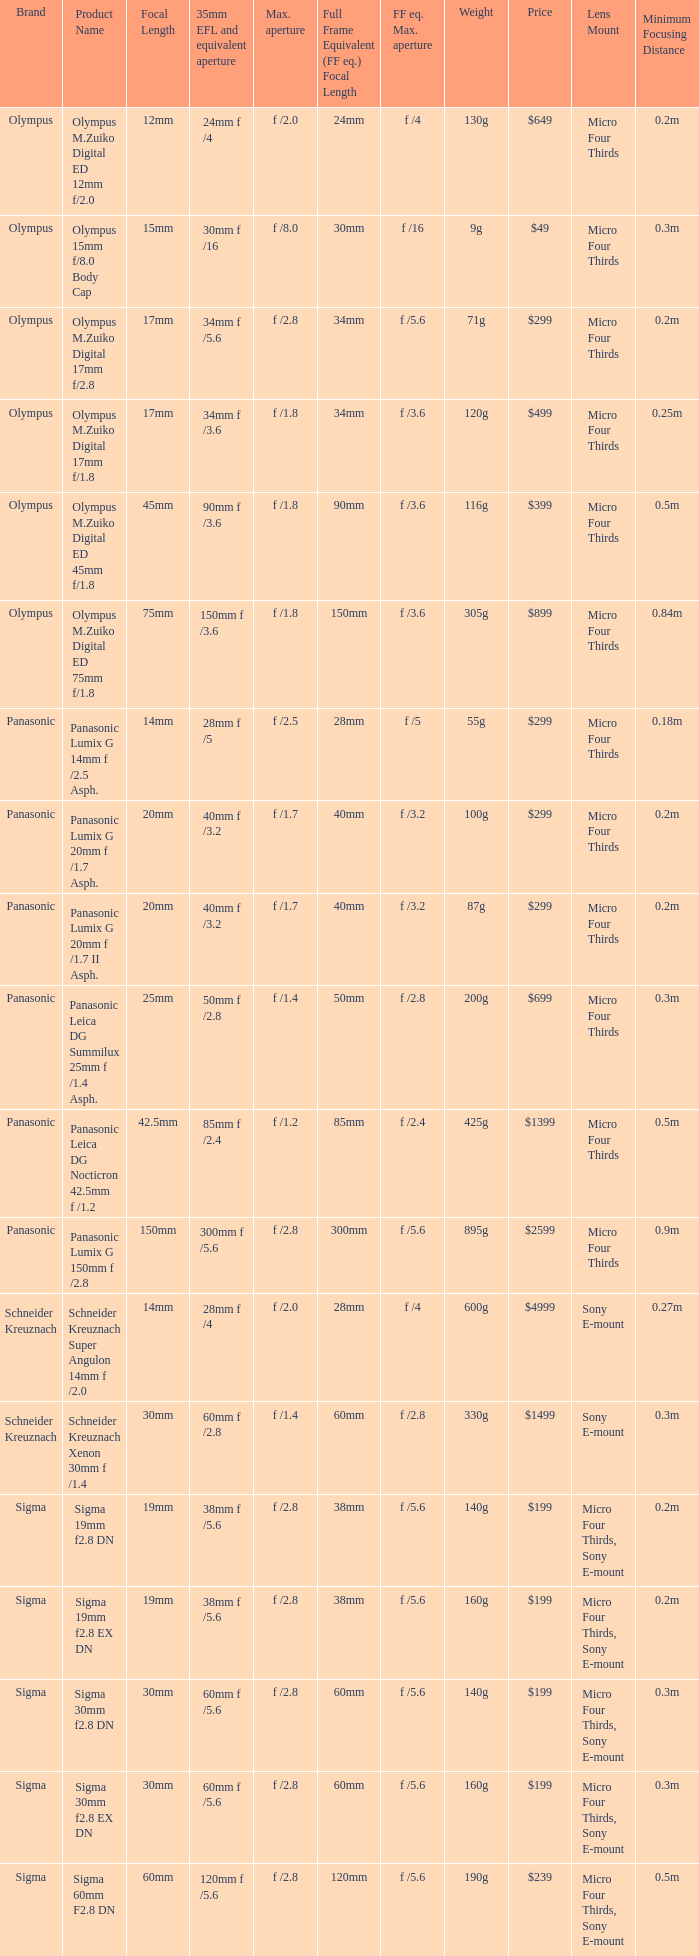Could you parse the entire table as a dict? {'header': ['Brand', 'Product Name', 'Focal Length', '35mm EFL and equivalent aperture', 'Max. aperture', 'Full Frame Equivalent (FF eq.) Focal Length', 'FF eq. Max. aperture', 'Weight', 'Price', 'Lens Mount', 'Minimum Focusing Distance'], 'rows': [['Olympus', 'Olympus M.Zuiko Digital ED 12mm f/2.0', '12mm', '24mm f /4', 'f /2.0', '24mm', 'f /4', '130g', '$649', 'Micro Four Thirds', '0.2m'], ['Olympus', 'Olympus 15mm f/8.0 Body Cap', '15mm', '30mm f /16', 'f /8.0', '30mm', 'f /16', '9g', '$49', 'Micro Four Thirds', '0.3m'], ['Olympus', 'Olympus M.Zuiko Digital 17mm f/2.8', '17mm', '34mm f /5.6', 'f /2.8', '34mm', 'f /5.6', '71g', '$299', 'Micro Four Thirds', '0.2m'], ['Olympus', 'Olympus M.Zuiko Digital 17mm f/1.8', '17mm', '34mm f /3.6', 'f /1.8', '34mm', 'f /3.6', '120g', '$499', 'Micro Four Thirds', '0.25m'], ['Olympus', 'Olympus M.Zuiko Digital ED 45mm f/1.8', '45mm', '90mm f /3.6', 'f /1.8', '90mm', 'f /3.6', '116g', '$399', 'Micro Four Thirds', '0.5m'], ['Olympus', 'Olympus M.Zuiko Digital ED 75mm f/1.8', '75mm', '150mm f /3.6', 'f /1.8', '150mm', 'f /3.6', '305g', '$899', 'Micro Four Thirds', '0.84m'], ['Panasonic', 'Panasonic Lumix G 14mm f /2.5 Asph.', '14mm', '28mm f /5', 'f /2.5', '28mm', 'f /5', '55g', '$299', 'Micro Four Thirds', '0.18m'], ['Panasonic', 'Panasonic Lumix G 20mm f /1.7 Asph.', '20mm', '40mm f /3.2', 'f /1.7', '40mm', 'f /3.2', '100g', '$299', 'Micro Four Thirds', '0.2m'], ['Panasonic', 'Panasonic Lumix G 20mm f /1.7 II Asph.', '20mm', '40mm f /3.2', 'f /1.7', '40mm', 'f /3.2', '87g', '$299', 'Micro Four Thirds', '0.2m'], ['Panasonic', 'Panasonic Leica DG Summilux 25mm f /1.4 Asph.', '25mm', '50mm f /2.8', 'f /1.4', '50mm', 'f /2.8', '200g', '$699', 'Micro Four Thirds', '0.3m'], ['Panasonic', 'Panasonic Leica DG Nocticron 42.5mm f /1.2', '42.5mm', '85mm f /2.4', 'f /1.2', '85mm', 'f /2.4', '425g', '$1399', 'Micro Four Thirds', '0.5m'], ['Panasonic', 'Panasonic Lumix G 150mm f /2.8', '150mm', '300mm f /5.6', 'f /2.8', '300mm', 'f /5.6', '895g', '$2599', 'Micro Four Thirds', '0.9m'], ['Schneider Kreuznach', 'Schneider Kreuznach Super Angulon 14mm f /2.0', '14mm', '28mm f /4', 'f /2.0', '28mm', 'f /4', '600g', '$4999', 'Sony E-mount', '0.27m'], ['Schneider Kreuznach', 'Schneider Kreuznach Xenon 30mm f /1.4', '30mm', '60mm f /2.8', 'f /1.4', '60mm', 'f /2.8', '330g', '$1499', 'Sony E-mount', '0.3m'], ['Sigma', 'Sigma 19mm f2.8 DN', '19mm', '38mm f /5.6', 'f /2.8', '38mm', 'f /5.6', '140g', '$199', 'Micro Four Thirds, Sony E-mount', '0.2m'], ['Sigma', 'Sigma 19mm f2.8 EX DN', '19mm', '38mm f /5.6', 'f /2.8', '38mm', 'f /5.6', '160g', '$199', 'Micro Four Thirds, Sony E-mount', '0.2m'], ['Sigma', 'Sigma 30mm f2.8 DN', '30mm', '60mm f /5.6', 'f /2.8', '60mm', 'f /5.6', '140g', '$199', 'Micro Four Thirds, Sony E-mount', '0.3m'], ['Sigma', 'Sigma 30mm f2.8 EX DN', '30mm', '60mm f /5.6', 'f /2.8', '60mm', 'f /5.6', '160g', '$199', 'Micro Four Thirds, Sony E-mount', '0.3m'], ['Sigma', 'Sigma 60mm F2.8 DN', '60mm', '120mm f /5.6', 'f /2.8', '120mm', 'f /5.6', '190g', '$239', 'Micro Four Thirds, Sony E-mount', '0.5m']]} What is the brand of the Sigma 30mm f2.8 DN, which has a maximum aperture of f /2.8 and a focal length of 30mm? Sigma. 